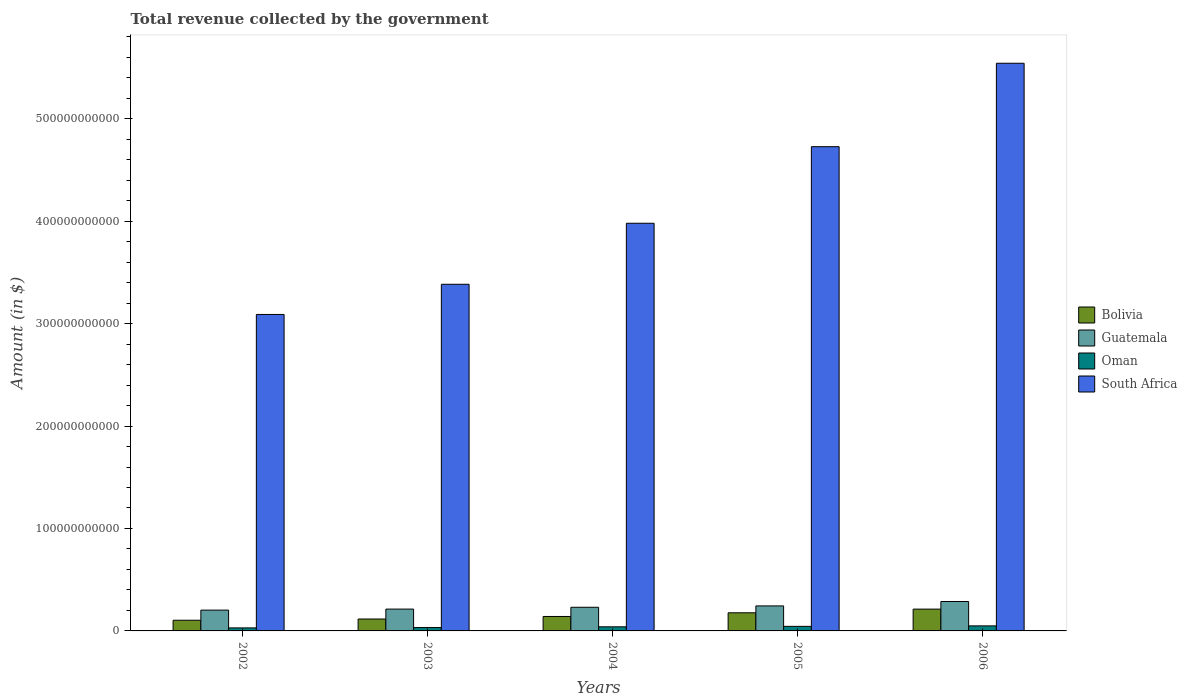Are the number of bars per tick equal to the number of legend labels?
Provide a short and direct response. Yes. Are the number of bars on each tick of the X-axis equal?
Make the answer very short. Yes. In how many cases, is the number of bars for a given year not equal to the number of legend labels?
Your answer should be very brief. 0. What is the total revenue collected by the government in Bolivia in 2005?
Keep it short and to the point. 1.77e+1. Across all years, what is the maximum total revenue collected by the government in South Africa?
Offer a terse response. 5.54e+11. Across all years, what is the minimum total revenue collected by the government in Bolivia?
Ensure brevity in your answer.  1.04e+1. In which year was the total revenue collected by the government in Oman maximum?
Provide a short and direct response. 2006. What is the total total revenue collected by the government in Bolivia in the graph?
Your answer should be very brief. 7.51e+1. What is the difference between the total revenue collected by the government in Bolivia in 2002 and that in 2004?
Give a very brief answer. -3.68e+09. What is the difference between the total revenue collected by the government in Oman in 2005 and the total revenue collected by the government in Guatemala in 2002?
Give a very brief answer. -1.59e+1. What is the average total revenue collected by the government in Oman per year?
Provide a succinct answer. 3.92e+09. In the year 2003, what is the difference between the total revenue collected by the government in Oman and total revenue collected by the government in Guatemala?
Keep it short and to the point. -1.80e+1. What is the ratio of the total revenue collected by the government in Guatemala in 2003 to that in 2004?
Provide a succinct answer. 0.92. Is the difference between the total revenue collected by the government in Oman in 2002 and 2004 greater than the difference between the total revenue collected by the government in Guatemala in 2002 and 2004?
Make the answer very short. Yes. What is the difference between the highest and the second highest total revenue collected by the government in Oman?
Keep it short and to the point. 4.69e+08. What is the difference between the highest and the lowest total revenue collected by the government in South Africa?
Your response must be concise. 2.45e+11. Is the sum of the total revenue collected by the government in Guatemala in 2004 and 2005 greater than the maximum total revenue collected by the government in Bolivia across all years?
Give a very brief answer. Yes. What does the 4th bar from the left in 2006 represents?
Your answer should be very brief. South Africa. What is the difference between two consecutive major ticks on the Y-axis?
Provide a short and direct response. 1.00e+11. Are the values on the major ticks of Y-axis written in scientific E-notation?
Your response must be concise. No. Does the graph contain grids?
Your answer should be very brief. No. Where does the legend appear in the graph?
Make the answer very short. Center right. How many legend labels are there?
Provide a succinct answer. 4. How are the legend labels stacked?
Give a very brief answer. Vertical. What is the title of the graph?
Provide a short and direct response. Total revenue collected by the government. What is the label or title of the Y-axis?
Provide a succinct answer. Amount (in $). What is the Amount (in $) in Bolivia in 2002?
Provide a short and direct response. 1.04e+1. What is the Amount (in $) in Guatemala in 2002?
Provide a succinct answer. 2.03e+1. What is the Amount (in $) of Oman in 2002?
Provide a short and direct response. 2.95e+09. What is the Amount (in $) of South Africa in 2002?
Give a very brief answer. 3.09e+11. What is the Amount (in $) of Bolivia in 2003?
Ensure brevity in your answer.  1.16e+1. What is the Amount (in $) of Guatemala in 2003?
Make the answer very short. 2.13e+1. What is the Amount (in $) of Oman in 2003?
Give a very brief answer. 3.28e+09. What is the Amount (in $) in South Africa in 2003?
Your answer should be very brief. 3.38e+11. What is the Amount (in $) of Bolivia in 2004?
Make the answer very short. 1.41e+1. What is the Amount (in $) of Guatemala in 2004?
Ensure brevity in your answer.  2.31e+1. What is the Amount (in $) in Oman in 2004?
Provide a succinct answer. 4.01e+09. What is the Amount (in $) in South Africa in 2004?
Your answer should be very brief. 3.98e+11. What is the Amount (in $) of Bolivia in 2005?
Keep it short and to the point. 1.77e+1. What is the Amount (in $) in Guatemala in 2005?
Give a very brief answer. 2.44e+1. What is the Amount (in $) in Oman in 2005?
Your answer should be compact. 4.44e+09. What is the Amount (in $) of South Africa in 2005?
Provide a short and direct response. 4.73e+11. What is the Amount (in $) of Bolivia in 2006?
Keep it short and to the point. 2.13e+1. What is the Amount (in $) of Guatemala in 2006?
Provide a short and direct response. 2.87e+1. What is the Amount (in $) of Oman in 2006?
Ensure brevity in your answer.  4.91e+09. What is the Amount (in $) in South Africa in 2006?
Your response must be concise. 5.54e+11. Across all years, what is the maximum Amount (in $) of Bolivia?
Your response must be concise. 2.13e+1. Across all years, what is the maximum Amount (in $) in Guatemala?
Make the answer very short. 2.87e+1. Across all years, what is the maximum Amount (in $) of Oman?
Make the answer very short. 4.91e+09. Across all years, what is the maximum Amount (in $) in South Africa?
Provide a short and direct response. 5.54e+11. Across all years, what is the minimum Amount (in $) of Bolivia?
Your answer should be very brief. 1.04e+1. Across all years, what is the minimum Amount (in $) in Guatemala?
Provide a short and direct response. 2.03e+1. Across all years, what is the minimum Amount (in $) of Oman?
Provide a succinct answer. 2.95e+09. Across all years, what is the minimum Amount (in $) in South Africa?
Make the answer very short. 3.09e+11. What is the total Amount (in $) of Bolivia in the graph?
Offer a very short reply. 7.51e+1. What is the total Amount (in $) of Guatemala in the graph?
Make the answer very short. 1.18e+11. What is the total Amount (in $) in Oman in the graph?
Provide a short and direct response. 1.96e+1. What is the total Amount (in $) in South Africa in the graph?
Give a very brief answer. 2.07e+12. What is the difference between the Amount (in $) in Bolivia in 2002 and that in 2003?
Your answer should be very brief. -1.22e+09. What is the difference between the Amount (in $) of Guatemala in 2002 and that in 2003?
Keep it short and to the point. -1.02e+09. What is the difference between the Amount (in $) of Oman in 2002 and that in 2003?
Ensure brevity in your answer.  -3.28e+08. What is the difference between the Amount (in $) of South Africa in 2002 and that in 2003?
Offer a very short reply. -2.95e+1. What is the difference between the Amount (in $) in Bolivia in 2002 and that in 2004?
Offer a very short reply. -3.68e+09. What is the difference between the Amount (in $) of Guatemala in 2002 and that in 2004?
Your answer should be very brief. -2.78e+09. What is the difference between the Amount (in $) in Oman in 2002 and that in 2004?
Provide a succinct answer. -1.05e+09. What is the difference between the Amount (in $) in South Africa in 2002 and that in 2004?
Make the answer very short. -8.90e+1. What is the difference between the Amount (in $) in Bolivia in 2002 and that in 2005?
Make the answer very short. -7.28e+09. What is the difference between the Amount (in $) in Guatemala in 2002 and that in 2005?
Provide a short and direct response. -4.10e+09. What is the difference between the Amount (in $) of Oman in 2002 and that in 2005?
Make the answer very short. -1.49e+09. What is the difference between the Amount (in $) in South Africa in 2002 and that in 2005?
Provide a short and direct response. -1.64e+11. What is the difference between the Amount (in $) in Bolivia in 2002 and that in 2006?
Offer a very short reply. -1.09e+1. What is the difference between the Amount (in $) in Guatemala in 2002 and that in 2006?
Provide a short and direct response. -8.43e+09. What is the difference between the Amount (in $) of Oman in 2002 and that in 2006?
Keep it short and to the point. -1.96e+09. What is the difference between the Amount (in $) of South Africa in 2002 and that in 2006?
Your response must be concise. -2.45e+11. What is the difference between the Amount (in $) of Bolivia in 2003 and that in 2004?
Offer a very short reply. -2.46e+09. What is the difference between the Amount (in $) in Guatemala in 2003 and that in 2004?
Your answer should be very brief. -1.76e+09. What is the difference between the Amount (in $) in Oman in 2003 and that in 2004?
Provide a short and direct response. -7.26e+08. What is the difference between the Amount (in $) in South Africa in 2003 and that in 2004?
Keep it short and to the point. -5.96e+1. What is the difference between the Amount (in $) of Bolivia in 2003 and that in 2005?
Offer a terse response. -6.06e+09. What is the difference between the Amount (in $) in Guatemala in 2003 and that in 2005?
Your response must be concise. -3.09e+09. What is the difference between the Amount (in $) of Oman in 2003 and that in 2005?
Provide a short and direct response. -1.16e+09. What is the difference between the Amount (in $) in South Africa in 2003 and that in 2005?
Your response must be concise. -1.34e+11. What is the difference between the Amount (in $) of Bolivia in 2003 and that in 2006?
Give a very brief answer. -9.65e+09. What is the difference between the Amount (in $) of Guatemala in 2003 and that in 2006?
Your answer should be very brief. -7.42e+09. What is the difference between the Amount (in $) of Oman in 2003 and that in 2006?
Your answer should be compact. -1.63e+09. What is the difference between the Amount (in $) of South Africa in 2003 and that in 2006?
Your response must be concise. -2.16e+11. What is the difference between the Amount (in $) of Bolivia in 2004 and that in 2005?
Offer a very short reply. -3.60e+09. What is the difference between the Amount (in $) of Guatemala in 2004 and that in 2005?
Your response must be concise. -1.33e+09. What is the difference between the Amount (in $) in Oman in 2004 and that in 2005?
Your answer should be compact. -4.38e+08. What is the difference between the Amount (in $) in South Africa in 2004 and that in 2005?
Your answer should be very brief. -7.47e+1. What is the difference between the Amount (in $) in Bolivia in 2004 and that in 2006?
Give a very brief answer. -7.20e+09. What is the difference between the Amount (in $) in Guatemala in 2004 and that in 2006?
Your response must be concise. -5.66e+09. What is the difference between the Amount (in $) of Oman in 2004 and that in 2006?
Provide a short and direct response. -9.07e+08. What is the difference between the Amount (in $) of South Africa in 2004 and that in 2006?
Keep it short and to the point. -1.56e+11. What is the difference between the Amount (in $) of Bolivia in 2005 and that in 2006?
Keep it short and to the point. -3.59e+09. What is the difference between the Amount (in $) of Guatemala in 2005 and that in 2006?
Provide a succinct answer. -4.33e+09. What is the difference between the Amount (in $) of Oman in 2005 and that in 2006?
Make the answer very short. -4.69e+08. What is the difference between the Amount (in $) in South Africa in 2005 and that in 2006?
Ensure brevity in your answer.  -8.14e+1. What is the difference between the Amount (in $) in Bolivia in 2002 and the Amount (in $) in Guatemala in 2003?
Offer a terse response. -1.09e+1. What is the difference between the Amount (in $) of Bolivia in 2002 and the Amount (in $) of Oman in 2003?
Make the answer very short. 7.14e+09. What is the difference between the Amount (in $) in Bolivia in 2002 and the Amount (in $) in South Africa in 2003?
Offer a terse response. -3.28e+11. What is the difference between the Amount (in $) in Guatemala in 2002 and the Amount (in $) in Oman in 2003?
Your answer should be very brief. 1.70e+1. What is the difference between the Amount (in $) in Guatemala in 2002 and the Amount (in $) in South Africa in 2003?
Make the answer very short. -3.18e+11. What is the difference between the Amount (in $) of Oman in 2002 and the Amount (in $) of South Africa in 2003?
Keep it short and to the point. -3.35e+11. What is the difference between the Amount (in $) of Bolivia in 2002 and the Amount (in $) of Guatemala in 2004?
Keep it short and to the point. -1.27e+1. What is the difference between the Amount (in $) of Bolivia in 2002 and the Amount (in $) of Oman in 2004?
Give a very brief answer. 6.41e+09. What is the difference between the Amount (in $) in Bolivia in 2002 and the Amount (in $) in South Africa in 2004?
Your answer should be compact. -3.88e+11. What is the difference between the Amount (in $) of Guatemala in 2002 and the Amount (in $) of Oman in 2004?
Make the answer very short. 1.63e+1. What is the difference between the Amount (in $) in Guatemala in 2002 and the Amount (in $) in South Africa in 2004?
Make the answer very short. -3.78e+11. What is the difference between the Amount (in $) of Oman in 2002 and the Amount (in $) of South Africa in 2004?
Your answer should be very brief. -3.95e+11. What is the difference between the Amount (in $) in Bolivia in 2002 and the Amount (in $) in Guatemala in 2005?
Make the answer very short. -1.40e+1. What is the difference between the Amount (in $) in Bolivia in 2002 and the Amount (in $) in Oman in 2005?
Your response must be concise. 5.97e+09. What is the difference between the Amount (in $) in Bolivia in 2002 and the Amount (in $) in South Africa in 2005?
Your answer should be compact. -4.62e+11. What is the difference between the Amount (in $) in Guatemala in 2002 and the Amount (in $) in Oman in 2005?
Give a very brief answer. 1.59e+1. What is the difference between the Amount (in $) in Guatemala in 2002 and the Amount (in $) in South Africa in 2005?
Offer a terse response. -4.52e+11. What is the difference between the Amount (in $) in Oman in 2002 and the Amount (in $) in South Africa in 2005?
Your answer should be very brief. -4.70e+11. What is the difference between the Amount (in $) of Bolivia in 2002 and the Amount (in $) of Guatemala in 2006?
Offer a very short reply. -1.83e+1. What is the difference between the Amount (in $) in Bolivia in 2002 and the Amount (in $) in Oman in 2006?
Your answer should be compact. 5.50e+09. What is the difference between the Amount (in $) in Bolivia in 2002 and the Amount (in $) in South Africa in 2006?
Keep it short and to the point. -5.44e+11. What is the difference between the Amount (in $) in Guatemala in 2002 and the Amount (in $) in Oman in 2006?
Your response must be concise. 1.54e+1. What is the difference between the Amount (in $) in Guatemala in 2002 and the Amount (in $) in South Africa in 2006?
Your answer should be compact. -5.34e+11. What is the difference between the Amount (in $) in Oman in 2002 and the Amount (in $) in South Africa in 2006?
Keep it short and to the point. -5.51e+11. What is the difference between the Amount (in $) in Bolivia in 2003 and the Amount (in $) in Guatemala in 2004?
Your answer should be very brief. -1.14e+1. What is the difference between the Amount (in $) of Bolivia in 2003 and the Amount (in $) of Oman in 2004?
Your response must be concise. 7.63e+09. What is the difference between the Amount (in $) in Bolivia in 2003 and the Amount (in $) in South Africa in 2004?
Keep it short and to the point. -3.86e+11. What is the difference between the Amount (in $) in Guatemala in 2003 and the Amount (in $) in Oman in 2004?
Offer a very short reply. 1.73e+1. What is the difference between the Amount (in $) in Guatemala in 2003 and the Amount (in $) in South Africa in 2004?
Your answer should be very brief. -3.77e+11. What is the difference between the Amount (in $) in Oman in 2003 and the Amount (in $) in South Africa in 2004?
Give a very brief answer. -3.95e+11. What is the difference between the Amount (in $) in Bolivia in 2003 and the Amount (in $) in Guatemala in 2005?
Offer a terse response. -1.28e+1. What is the difference between the Amount (in $) in Bolivia in 2003 and the Amount (in $) in Oman in 2005?
Your answer should be compact. 7.19e+09. What is the difference between the Amount (in $) of Bolivia in 2003 and the Amount (in $) of South Africa in 2005?
Offer a terse response. -4.61e+11. What is the difference between the Amount (in $) of Guatemala in 2003 and the Amount (in $) of Oman in 2005?
Offer a very short reply. 1.69e+1. What is the difference between the Amount (in $) in Guatemala in 2003 and the Amount (in $) in South Africa in 2005?
Provide a succinct answer. -4.51e+11. What is the difference between the Amount (in $) in Oman in 2003 and the Amount (in $) in South Africa in 2005?
Offer a terse response. -4.69e+11. What is the difference between the Amount (in $) of Bolivia in 2003 and the Amount (in $) of Guatemala in 2006?
Ensure brevity in your answer.  -1.71e+1. What is the difference between the Amount (in $) of Bolivia in 2003 and the Amount (in $) of Oman in 2006?
Make the answer very short. 6.72e+09. What is the difference between the Amount (in $) of Bolivia in 2003 and the Amount (in $) of South Africa in 2006?
Your response must be concise. -5.42e+11. What is the difference between the Amount (in $) in Guatemala in 2003 and the Amount (in $) in Oman in 2006?
Provide a short and direct response. 1.64e+1. What is the difference between the Amount (in $) of Guatemala in 2003 and the Amount (in $) of South Africa in 2006?
Your response must be concise. -5.33e+11. What is the difference between the Amount (in $) in Oman in 2003 and the Amount (in $) in South Africa in 2006?
Your response must be concise. -5.51e+11. What is the difference between the Amount (in $) in Bolivia in 2004 and the Amount (in $) in Guatemala in 2005?
Your answer should be very brief. -1.03e+1. What is the difference between the Amount (in $) of Bolivia in 2004 and the Amount (in $) of Oman in 2005?
Provide a succinct answer. 9.65e+09. What is the difference between the Amount (in $) of Bolivia in 2004 and the Amount (in $) of South Africa in 2005?
Provide a short and direct response. -4.59e+11. What is the difference between the Amount (in $) in Guatemala in 2004 and the Amount (in $) in Oman in 2005?
Offer a terse response. 1.86e+1. What is the difference between the Amount (in $) in Guatemala in 2004 and the Amount (in $) in South Africa in 2005?
Offer a very short reply. -4.50e+11. What is the difference between the Amount (in $) of Oman in 2004 and the Amount (in $) of South Africa in 2005?
Your answer should be compact. -4.69e+11. What is the difference between the Amount (in $) in Bolivia in 2004 and the Amount (in $) in Guatemala in 2006?
Ensure brevity in your answer.  -1.46e+1. What is the difference between the Amount (in $) of Bolivia in 2004 and the Amount (in $) of Oman in 2006?
Offer a very short reply. 9.18e+09. What is the difference between the Amount (in $) in Bolivia in 2004 and the Amount (in $) in South Africa in 2006?
Offer a terse response. -5.40e+11. What is the difference between the Amount (in $) of Guatemala in 2004 and the Amount (in $) of Oman in 2006?
Make the answer very short. 1.82e+1. What is the difference between the Amount (in $) in Guatemala in 2004 and the Amount (in $) in South Africa in 2006?
Provide a short and direct response. -5.31e+11. What is the difference between the Amount (in $) of Oman in 2004 and the Amount (in $) of South Africa in 2006?
Offer a very short reply. -5.50e+11. What is the difference between the Amount (in $) of Bolivia in 2005 and the Amount (in $) of Guatemala in 2006?
Ensure brevity in your answer.  -1.10e+1. What is the difference between the Amount (in $) in Bolivia in 2005 and the Amount (in $) in Oman in 2006?
Keep it short and to the point. 1.28e+1. What is the difference between the Amount (in $) of Bolivia in 2005 and the Amount (in $) of South Africa in 2006?
Provide a succinct answer. -5.36e+11. What is the difference between the Amount (in $) in Guatemala in 2005 and the Amount (in $) in Oman in 2006?
Keep it short and to the point. 1.95e+1. What is the difference between the Amount (in $) of Guatemala in 2005 and the Amount (in $) of South Africa in 2006?
Keep it short and to the point. -5.30e+11. What is the difference between the Amount (in $) of Oman in 2005 and the Amount (in $) of South Africa in 2006?
Offer a very short reply. -5.50e+11. What is the average Amount (in $) of Bolivia per year?
Provide a short and direct response. 1.50e+1. What is the average Amount (in $) of Guatemala per year?
Your response must be concise. 2.36e+1. What is the average Amount (in $) in Oman per year?
Ensure brevity in your answer.  3.92e+09. What is the average Amount (in $) in South Africa per year?
Keep it short and to the point. 4.14e+11. In the year 2002, what is the difference between the Amount (in $) in Bolivia and Amount (in $) in Guatemala?
Offer a very short reply. -9.88e+09. In the year 2002, what is the difference between the Amount (in $) in Bolivia and Amount (in $) in Oman?
Give a very brief answer. 7.46e+09. In the year 2002, what is the difference between the Amount (in $) of Bolivia and Amount (in $) of South Africa?
Your answer should be very brief. -2.98e+11. In the year 2002, what is the difference between the Amount (in $) of Guatemala and Amount (in $) of Oman?
Your response must be concise. 1.73e+1. In the year 2002, what is the difference between the Amount (in $) in Guatemala and Amount (in $) in South Africa?
Provide a succinct answer. -2.89e+11. In the year 2002, what is the difference between the Amount (in $) of Oman and Amount (in $) of South Africa?
Ensure brevity in your answer.  -3.06e+11. In the year 2003, what is the difference between the Amount (in $) of Bolivia and Amount (in $) of Guatemala?
Make the answer very short. -9.68e+09. In the year 2003, what is the difference between the Amount (in $) in Bolivia and Amount (in $) in Oman?
Offer a terse response. 8.35e+09. In the year 2003, what is the difference between the Amount (in $) of Bolivia and Amount (in $) of South Africa?
Ensure brevity in your answer.  -3.27e+11. In the year 2003, what is the difference between the Amount (in $) of Guatemala and Amount (in $) of Oman?
Your response must be concise. 1.80e+1. In the year 2003, what is the difference between the Amount (in $) in Guatemala and Amount (in $) in South Africa?
Make the answer very short. -3.17e+11. In the year 2003, what is the difference between the Amount (in $) of Oman and Amount (in $) of South Africa?
Ensure brevity in your answer.  -3.35e+11. In the year 2004, what is the difference between the Amount (in $) of Bolivia and Amount (in $) of Guatemala?
Ensure brevity in your answer.  -8.98e+09. In the year 2004, what is the difference between the Amount (in $) of Bolivia and Amount (in $) of Oman?
Ensure brevity in your answer.  1.01e+1. In the year 2004, what is the difference between the Amount (in $) of Bolivia and Amount (in $) of South Africa?
Provide a succinct answer. -3.84e+11. In the year 2004, what is the difference between the Amount (in $) of Guatemala and Amount (in $) of Oman?
Offer a very short reply. 1.91e+1. In the year 2004, what is the difference between the Amount (in $) in Guatemala and Amount (in $) in South Africa?
Give a very brief answer. -3.75e+11. In the year 2004, what is the difference between the Amount (in $) in Oman and Amount (in $) in South Africa?
Ensure brevity in your answer.  -3.94e+11. In the year 2005, what is the difference between the Amount (in $) of Bolivia and Amount (in $) of Guatemala?
Provide a short and direct response. -6.71e+09. In the year 2005, what is the difference between the Amount (in $) in Bolivia and Amount (in $) in Oman?
Provide a short and direct response. 1.33e+1. In the year 2005, what is the difference between the Amount (in $) in Bolivia and Amount (in $) in South Africa?
Keep it short and to the point. -4.55e+11. In the year 2005, what is the difference between the Amount (in $) of Guatemala and Amount (in $) of Oman?
Provide a short and direct response. 2.00e+1. In the year 2005, what is the difference between the Amount (in $) in Guatemala and Amount (in $) in South Africa?
Give a very brief answer. -4.48e+11. In the year 2005, what is the difference between the Amount (in $) in Oman and Amount (in $) in South Africa?
Your answer should be very brief. -4.68e+11. In the year 2006, what is the difference between the Amount (in $) of Bolivia and Amount (in $) of Guatemala?
Provide a short and direct response. -7.44e+09. In the year 2006, what is the difference between the Amount (in $) in Bolivia and Amount (in $) in Oman?
Offer a terse response. 1.64e+1. In the year 2006, what is the difference between the Amount (in $) of Bolivia and Amount (in $) of South Africa?
Provide a short and direct response. -5.33e+11. In the year 2006, what is the difference between the Amount (in $) in Guatemala and Amount (in $) in Oman?
Keep it short and to the point. 2.38e+1. In the year 2006, what is the difference between the Amount (in $) in Guatemala and Amount (in $) in South Africa?
Offer a terse response. -5.25e+11. In the year 2006, what is the difference between the Amount (in $) of Oman and Amount (in $) of South Africa?
Keep it short and to the point. -5.49e+11. What is the ratio of the Amount (in $) in Bolivia in 2002 to that in 2003?
Offer a terse response. 0.9. What is the ratio of the Amount (in $) in Guatemala in 2002 to that in 2003?
Your answer should be compact. 0.95. What is the ratio of the Amount (in $) of South Africa in 2002 to that in 2003?
Make the answer very short. 0.91. What is the ratio of the Amount (in $) in Bolivia in 2002 to that in 2004?
Offer a very short reply. 0.74. What is the ratio of the Amount (in $) in Guatemala in 2002 to that in 2004?
Your answer should be very brief. 0.88. What is the ratio of the Amount (in $) in Oman in 2002 to that in 2004?
Provide a succinct answer. 0.74. What is the ratio of the Amount (in $) in South Africa in 2002 to that in 2004?
Your answer should be very brief. 0.78. What is the ratio of the Amount (in $) of Bolivia in 2002 to that in 2005?
Offer a very short reply. 0.59. What is the ratio of the Amount (in $) of Guatemala in 2002 to that in 2005?
Provide a short and direct response. 0.83. What is the ratio of the Amount (in $) of Oman in 2002 to that in 2005?
Provide a short and direct response. 0.66. What is the ratio of the Amount (in $) in South Africa in 2002 to that in 2005?
Make the answer very short. 0.65. What is the ratio of the Amount (in $) in Bolivia in 2002 to that in 2006?
Give a very brief answer. 0.49. What is the ratio of the Amount (in $) in Guatemala in 2002 to that in 2006?
Ensure brevity in your answer.  0.71. What is the ratio of the Amount (in $) in Oman in 2002 to that in 2006?
Your answer should be very brief. 0.6. What is the ratio of the Amount (in $) in South Africa in 2002 to that in 2006?
Give a very brief answer. 0.56. What is the ratio of the Amount (in $) of Bolivia in 2003 to that in 2004?
Offer a very short reply. 0.83. What is the ratio of the Amount (in $) of Guatemala in 2003 to that in 2004?
Offer a terse response. 0.92. What is the ratio of the Amount (in $) in Oman in 2003 to that in 2004?
Offer a very short reply. 0.82. What is the ratio of the Amount (in $) in South Africa in 2003 to that in 2004?
Offer a very short reply. 0.85. What is the ratio of the Amount (in $) of Bolivia in 2003 to that in 2005?
Make the answer very short. 0.66. What is the ratio of the Amount (in $) of Guatemala in 2003 to that in 2005?
Make the answer very short. 0.87. What is the ratio of the Amount (in $) of Oman in 2003 to that in 2005?
Your answer should be very brief. 0.74. What is the ratio of the Amount (in $) in South Africa in 2003 to that in 2005?
Your answer should be compact. 0.72. What is the ratio of the Amount (in $) of Bolivia in 2003 to that in 2006?
Ensure brevity in your answer.  0.55. What is the ratio of the Amount (in $) in Guatemala in 2003 to that in 2006?
Offer a very short reply. 0.74. What is the ratio of the Amount (in $) of Oman in 2003 to that in 2006?
Keep it short and to the point. 0.67. What is the ratio of the Amount (in $) in South Africa in 2003 to that in 2006?
Your answer should be very brief. 0.61. What is the ratio of the Amount (in $) of Bolivia in 2004 to that in 2005?
Provide a succinct answer. 0.8. What is the ratio of the Amount (in $) in Guatemala in 2004 to that in 2005?
Your response must be concise. 0.95. What is the ratio of the Amount (in $) of Oman in 2004 to that in 2005?
Ensure brevity in your answer.  0.9. What is the ratio of the Amount (in $) of South Africa in 2004 to that in 2005?
Your answer should be compact. 0.84. What is the ratio of the Amount (in $) in Bolivia in 2004 to that in 2006?
Provide a succinct answer. 0.66. What is the ratio of the Amount (in $) in Guatemala in 2004 to that in 2006?
Your answer should be compact. 0.8. What is the ratio of the Amount (in $) of Oman in 2004 to that in 2006?
Offer a terse response. 0.82. What is the ratio of the Amount (in $) of South Africa in 2004 to that in 2006?
Provide a succinct answer. 0.72. What is the ratio of the Amount (in $) in Bolivia in 2005 to that in 2006?
Provide a succinct answer. 0.83. What is the ratio of the Amount (in $) in Guatemala in 2005 to that in 2006?
Make the answer very short. 0.85. What is the ratio of the Amount (in $) in Oman in 2005 to that in 2006?
Your response must be concise. 0.9. What is the ratio of the Amount (in $) of South Africa in 2005 to that in 2006?
Your answer should be compact. 0.85. What is the difference between the highest and the second highest Amount (in $) of Bolivia?
Ensure brevity in your answer.  3.59e+09. What is the difference between the highest and the second highest Amount (in $) of Guatemala?
Offer a very short reply. 4.33e+09. What is the difference between the highest and the second highest Amount (in $) of Oman?
Provide a short and direct response. 4.69e+08. What is the difference between the highest and the second highest Amount (in $) in South Africa?
Keep it short and to the point. 8.14e+1. What is the difference between the highest and the lowest Amount (in $) of Bolivia?
Your answer should be very brief. 1.09e+1. What is the difference between the highest and the lowest Amount (in $) in Guatemala?
Ensure brevity in your answer.  8.43e+09. What is the difference between the highest and the lowest Amount (in $) in Oman?
Your answer should be very brief. 1.96e+09. What is the difference between the highest and the lowest Amount (in $) of South Africa?
Ensure brevity in your answer.  2.45e+11. 